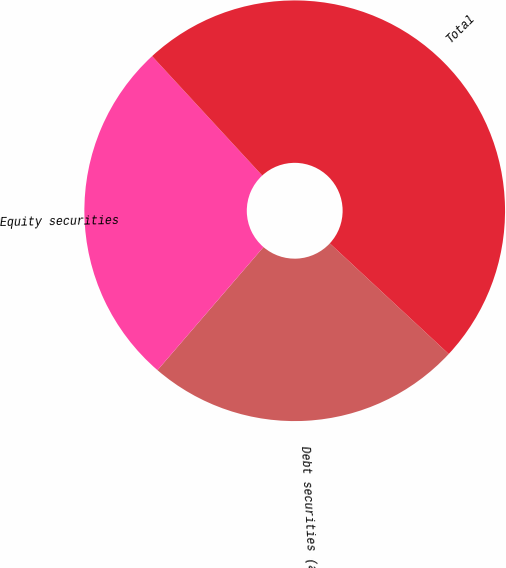<chart> <loc_0><loc_0><loc_500><loc_500><pie_chart><fcel>Debt securities (a)<fcel>Equity securities<fcel>Total<nl><fcel>24.39%<fcel>26.83%<fcel>48.78%<nl></chart> 